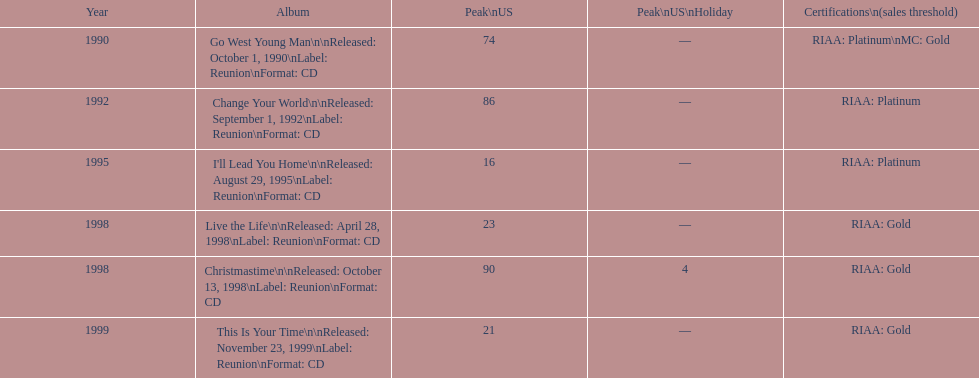What is the number of michael w smith albums that made it to the top 25 of the charts? 3. 